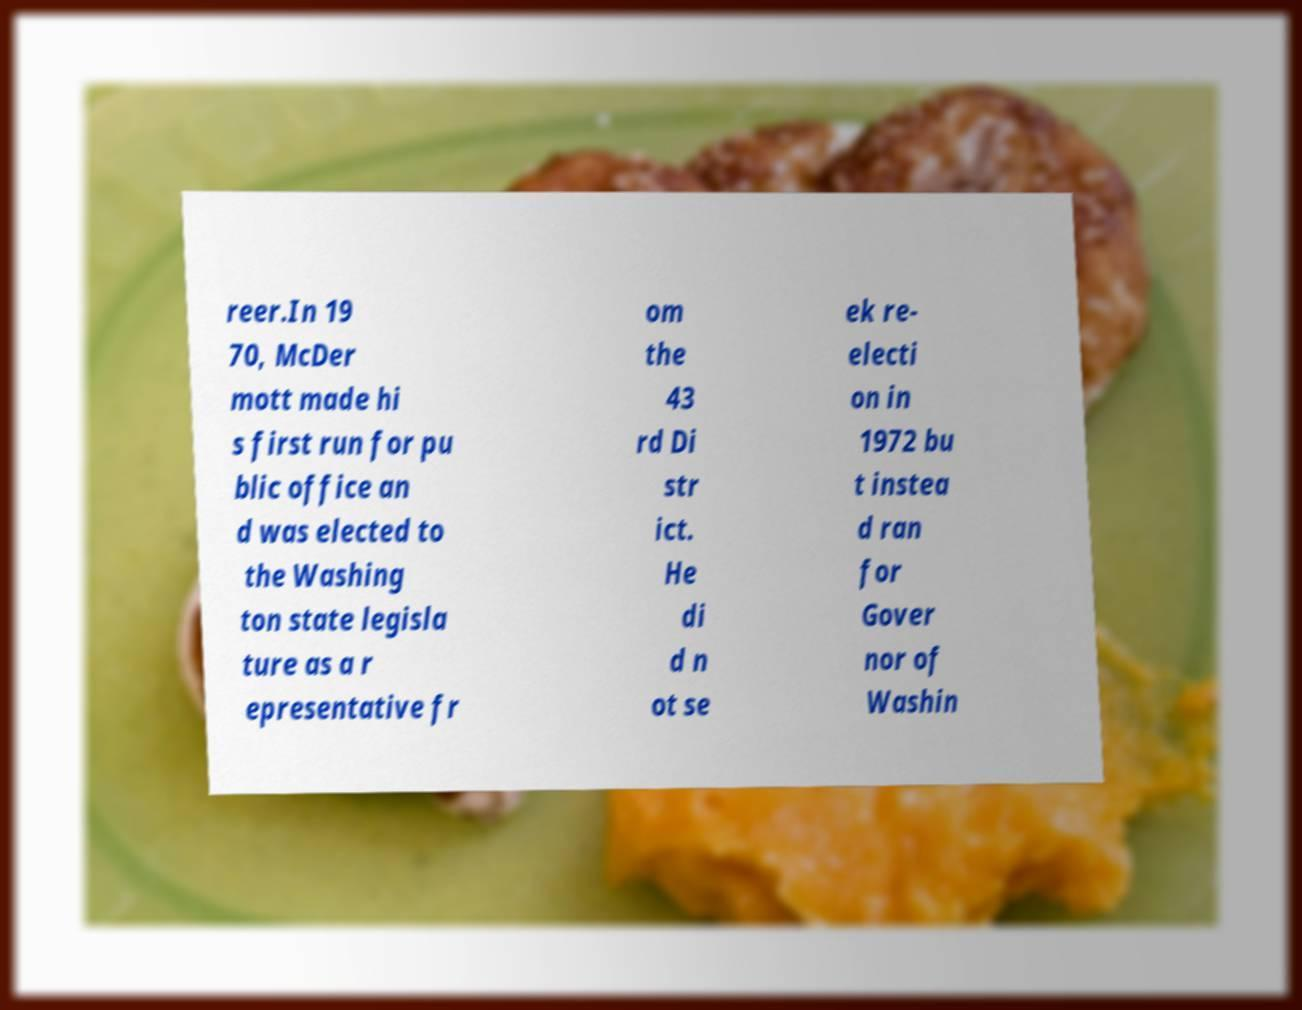Please read and relay the text visible in this image. What does it say? reer.In 19 70, McDer mott made hi s first run for pu blic office an d was elected to the Washing ton state legisla ture as a r epresentative fr om the 43 rd Di str ict. He di d n ot se ek re- electi on in 1972 bu t instea d ran for Gover nor of Washin 